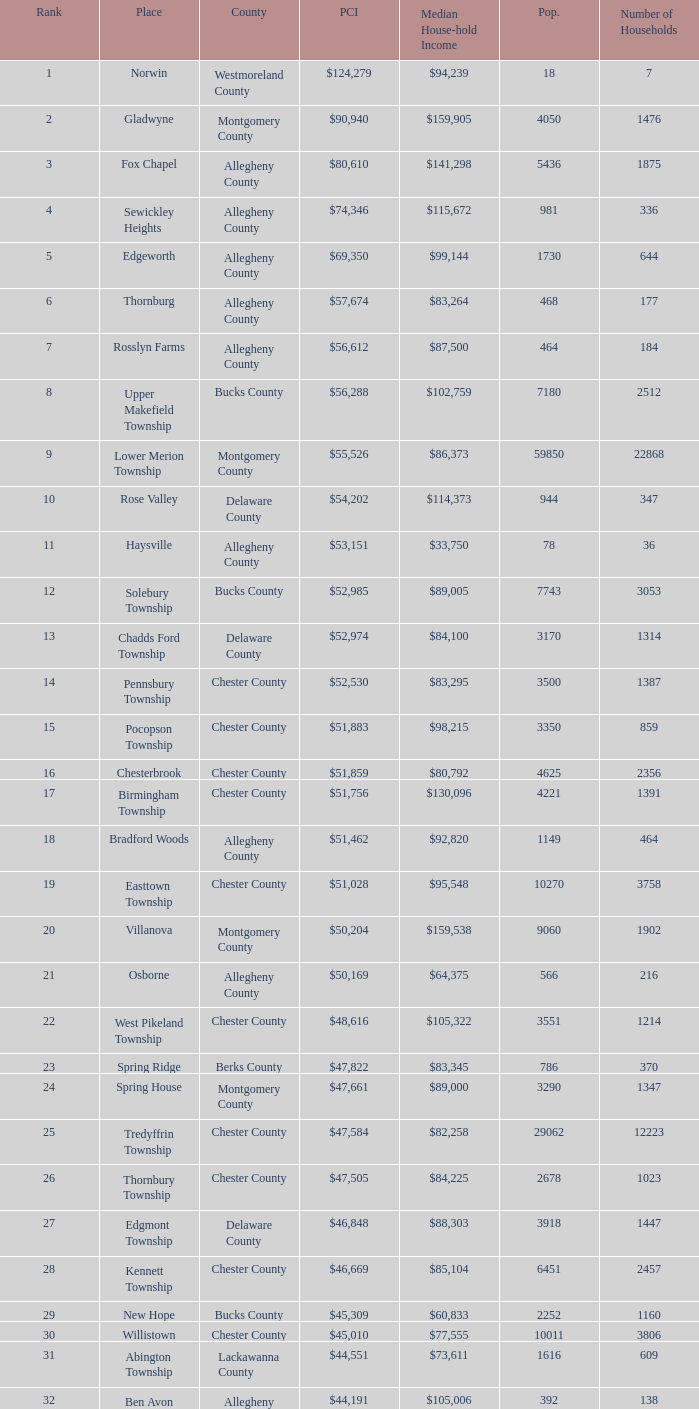Can you parse all the data within this table? {'header': ['Rank', 'Place', 'County', 'PCI', 'Median House-hold Income', 'Pop.', 'Number of Households'], 'rows': [['1', 'Norwin', 'Westmoreland County', '$124,279', '$94,239', '18', '7'], ['2', 'Gladwyne', 'Montgomery County', '$90,940', '$159,905', '4050', '1476'], ['3', 'Fox Chapel', 'Allegheny County', '$80,610', '$141,298', '5436', '1875'], ['4', 'Sewickley Heights', 'Allegheny County', '$74,346', '$115,672', '981', '336'], ['5', 'Edgeworth', 'Allegheny County', '$69,350', '$99,144', '1730', '644'], ['6', 'Thornburg', 'Allegheny County', '$57,674', '$83,264', '468', '177'], ['7', 'Rosslyn Farms', 'Allegheny County', '$56,612', '$87,500', '464', '184'], ['8', 'Upper Makefield Township', 'Bucks County', '$56,288', '$102,759', '7180', '2512'], ['9', 'Lower Merion Township', 'Montgomery County', '$55,526', '$86,373', '59850', '22868'], ['10', 'Rose Valley', 'Delaware County', '$54,202', '$114,373', '944', '347'], ['11', 'Haysville', 'Allegheny County', '$53,151', '$33,750', '78', '36'], ['12', 'Solebury Township', 'Bucks County', '$52,985', '$89,005', '7743', '3053'], ['13', 'Chadds Ford Township', 'Delaware County', '$52,974', '$84,100', '3170', '1314'], ['14', 'Pennsbury Township', 'Chester County', '$52,530', '$83,295', '3500', '1387'], ['15', 'Pocopson Township', 'Chester County', '$51,883', '$98,215', '3350', '859'], ['16', 'Chesterbrook', 'Chester County', '$51,859', '$80,792', '4625', '2356'], ['17', 'Birmingham Township', 'Chester County', '$51,756', '$130,096', '4221', '1391'], ['18', 'Bradford Woods', 'Allegheny County', '$51,462', '$92,820', '1149', '464'], ['19', 'Easttown Township', 'Chester County', '$51,028', '$95,548', '10270', '3758'], ['20', 'Villanova', 'Montgomery County', '$50,204', '$159,538', '9060', '1902'], ['21', 'Osborne', 'Allegheny County', '$50,169', '$64,375', '566', '216'], ['22', 'West Pikeland Township', 'Chester County', '$48,616', '$105,322', '3551', '1214'], ['23', 'Spring Ridge', 'Berks County', '$47,822', '$83,345', '786', '370'], ['24', 'Spring House', 'Montgomery County', '$47,661', '$89,000', '3290', '1347'], ['25', 'Tredyffrin Township', 'Chester County', '$47,584', '$82,258', '29062', '12223'], ['26', 'Thornbury Township', 'Chester County', '$47,505', '$84,225', '2678', '1023'], ['27', 'Edgmont Township', 'Delaware County', '$46,848', '$88,303', '3918', '1447'], ['28', 'Kennett Township', 'Chester County', '$46,669', '$85,104', '6451', '2457'], ['29', 'New Hope', 'Bucks County', '$45,309', '$60,833', '2252', '1160'], ['30', 'Willistown', 'Chester County', '$45,010', '$77,555', '10011', '3806'], ['31', 'Abington Township', 'Lackawanna County', '$44,551', '$73,611', '1616', '609'], ['32', 'Ben Avon Heights', 'Allegheny County', '$44,191', '$105,006', '392', '138'], ['33', 'Bala-Cynwyd', 'Montgomery County', '$44,027', '$78,932', '9336', '3726'], ['34', 'Lower Makefield Township', 'Bucks County', '$43,983', '$98,090', '32681', '11706'], ['35', 'Blue Bell', 'Montgomery County', '$43,813', '$94,160', '6395', '2434'], ['36', 'West Vincent Township', 'Chester County', '$43,500', '$92,024', '3170', '1077'], ['37', 'Mount Gretna', 'Lebanon County', '$43,470', '$62,917', '242', '117'], ['38', 'Schuylkill Township', 'Chester County', '$43,379', '$86,092', '6960', '2536'], ['39', 'Fort Washington', 'Montgomery County', '$43,090', '$103,469', '3680', '1161'], ['40', 'Marshall Township', 'Allegheny County', '$42,856', '$102,351', '5996', '1944'], ['41', 'Woodside', 'Bucks County', '$42,653', '$121,151', '2575', '791'], ['42', 'Wrightstown Township', 'Bucks County', '$42,623', '$82,875', '2839', '971'], ['43', 'Upper St.Clair Township', 'Allegheny County', '$42,413', '$87,581', '20053', '6966'], ['44', 'Seven Springs', 'Fayette County', '$42,131', '$48,750', '127', '63'], ['45', 'Charlestown Township', 'Chester County', '$41,878', '$89,813', '4051', '1340'], ['46', 'Lower Gwynedd Township', 'Montgomery County', '$41,868', '$74,351', '10422', '4177'], ['47', 'Whitpain Township', 'Montgomery County', '$41,739', '$88,933', '18562', '6960'], ['48', 'Bell Acres', 'Allegheny County', '$41,202', '$61,094', '1382', '520'], ['49', 'Penn Wynne', 'Montgomery County', '$41,199', '$78,398', '5382', '2072'], ['50', 'East Bradford Township', 'Chester County', '$41,158', '$100,732', '9405', '3076'], ['51', 'Swarthmore', 'Delaware County', '$40,482', '$82,653', '6170', '1993'], ['52', 'Lafayette Hill', 'Montgomery County', '$40,363', '$84,835', '10226', '3783'], ['53', 'Lower Moreland Township', 'Montgomery County', '$40,129', '$82,597', '11281', '4112'], ['54', 'Radnor Township', 'Delaware County', '$39,813', '$74,272', '30878', '10347'], ['55', 'Whitemarsh Township', 'Montgomery County', '$39,785', '$78,630', '16702', '6179'], ['56', 'Upper Providence Township', 'Delaware County', '$39,532', '$71,166', '10509', '4075'], ['57', 'Newtown Township', 'Delaware County', '$39,364', '$65,924', '11700', '4549'], ['58', 'Adams Township', 'Butler County', '$39,204', '$65,357', '6774', '2382'], ['59', 'Edgewood', 'Allegheny County', '$39,188', '$52,153', '3311', '1639'], ['60', 'Dresher', 'Montgomery County', '$38,865', '$99,231', '5610', '1765'], ['61', 'Sewickley Hills', 'Allegheny County', '$38,681', '$79,466', '652', '225'], ['62', 'Exton', 'Chester County', '$38,589', '$68,240', '4267', '2053'], ['63', 'East Marlborough Township', 'Chester County', '$38,090', '$95,812', '6317', '2131'], ['64', 'Doylestown Township', 'Bucks County', '$38,031', '$81,226', '17619', '5999'], ['65', 'Upper Dublin Township', 'Montgomery County', '$37,994', '$80,093', '25878', '9174'], ['66', 'Churchill', 'Allegheny County', '$37,964', '$67,321', '3566', '1519'], ['67', 'Franklin Park', 'Allegheny County', '$37,924', '$87,627', '11364', '3866'], ['68', 'East Goshen Township', 'Chester County', '$37,775', '$64,777', '16824', '7165'], ['69', 'Chester Heights', 'Delaware County', '$37,707', '$70,236', '2481', '1056'], ['70', 'McMurray', 'Washington County', '$37,364', '$81,736', '4726', '1582'], ['71', 'Wyomissing', 'Berks County', '$37,313', '$54,681', '8587', '3359'], ['72', 'Heath Township', 'Jefferson County', '$37,309', '$42,500', '160', '77'], ['73', 'Aleppo Township', 'Allegheny County', '$37,187', '$59,167', '1039', '483'], ['74', 'Westtown Township', 'Chester County', '$36,894', '$85,049', '10352', '3705'], ['75', 'Thompsonville', 'Washington County', '$36,853', '$75,000', '3592', '1228'], ['76', 'Flying Hills', 'Berks County', '$36,822', '$59,596', '1191', '592'], ['77', 'Newlin Township', 'Chester County', '$36,804', '$68,828', '1150', '429'], ['78', 'Wyndmoor', 'Montgomery County', '$36,205', '$72,219', '5601', '2144'], ['79', 'Peters Township', 'Washington County', '$36,159', '$77,442', '17566', '6026'], ['80', 'Ardmore', 'Montgomery County', '$36,111', '$60,966', '12616', '5529'], ['81', 'Clarks Green', 'Lackawanna County', '$35,975', '$61,250', '1630', '616'], ['82', 'London Britain Township', 'Chester County', '$35,761', '$93,521', '2797', '957'], ['83', 'Buckingham Township', 'Bucks County', '$35,735', '$82,376', '16422', '5711'], ['84', 'Devon-Berwyn', 'Chester County', '$35,551', '$74,886', '5067', '1978'], ['85', 'North Abington Township', 'Lackawanna County', '$35,537', '$57,917', '782', '258'], ['86', 'Malvern', 'Chester County', '$35,477', '$62,308', '3059', '1361'], ['87', 'Pine Township', 'Allegheny County', '$35,202', '$85,817', '7683', '2411'], ['88', 'Narberth', 'Montgomery County', '$35,165', '$60,408', '4233', '1904'], ['89', 'West Whiteland Township', 'Chester County', '$35,031', '$71,545', '16499', '6618'], ['90', 'Timber Hills', 'Lebanon County', '$34,974', '$55,938', '329', '157'], ['91', 'Upper Merion Township', 'Montgomery County', '$34,961', '$65,636', '26863', '11575'], ['92', 'Homewood', 'Beaver County', '$34,486', '$33,333', '147', '59'], ['93', 'Newtown Township', 'Bucks County', '$34,335', '$80,532', '18206', '6761'], ['94', 'Tinicum Township', 'Bucks County', '$34,321', '$60,843', '4206', '1674'], ['95', 'Worcester Township', 'Montgomery County', '$34,264', '$77,200', '7789', '2896'], ['96', 'Wyomissing Hills', 'Berks County', '$34,024', '$61,364', '2568', '986'], ['97', 'Woodbourne', 'Bucks County', '$33,821', '$107,913', '3512', '1008'], ['98', 'Concord Township', 'Delaware County', '$33,800', '$85,503', '9933', '3384'], ['99', 'Uwchlan Township', 'Chester County', '$33,785', '$81,985', '16576', '5921']]} Which place has a rank of 71? Wyomissing. 